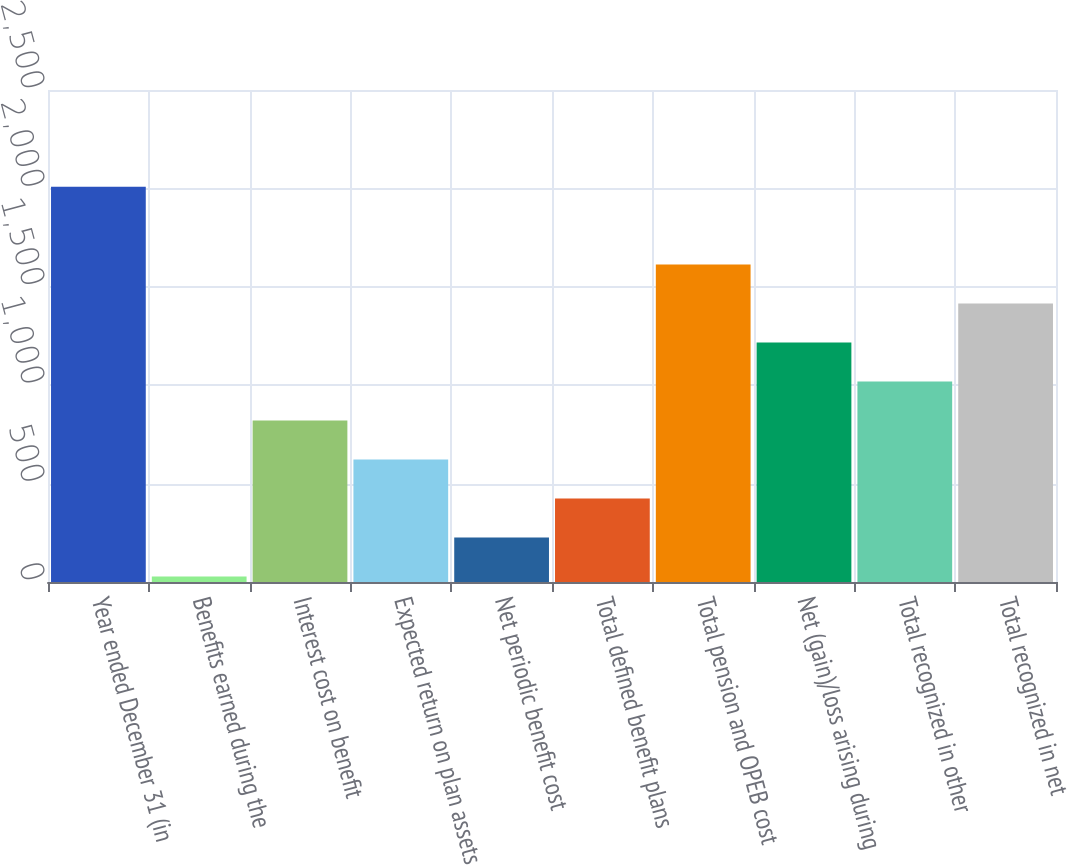<chart> <loc_0><loc_0><loc_500><loc_500><bar_chart><fcel>Year ended December 31 (in<fcel>Benefits earned during the<fcel>Interest cost on benefit<fcel>Expected return on plan assets<fcel>Net periodic benefit cost<fcel>Total defined benefit plans<fcel>Total pension and OPEB cost<fcel>Net (gain)/loss arising during<fcel>Total recognized in other<fcel>Total recognized in net<nl><fcel>2009<fcel>28<fcel>820.4<fcel>622.3<fcel>226.1<fcel>424.2<fcel>1612.8<fcel>1216.6<fcel>1018.5<fcel>1414.7<nl></chart> 